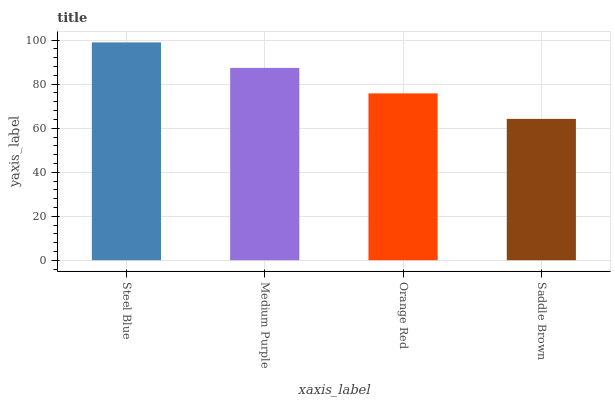Is Saddle Brown the minimum?
Answer yes or no. Yes. Is Steel Blue the maximum?
Answer yes or no. Yes. Is Medium Purple the minimum?
Answer yes or no. No. Is Medium Purple the maximum?
Answer yes or no. No. Is Steel Blue greater than Medium Purple?
Answer yes or no. Yes. Is Medium Purple less than Steel Blue?
Answer yes or no. Yes. Is Medium Purple greater than Steel Blue?
Answer yes or no. No. Is Steel Blue less than Medium Purple?
Answer yes or no. No. Is Medium Purple the high median?
Answer yes or no. Yes. Is Orange Red the low median?
Answer yes or no. Yes. Is Orange Red the high median?
Answer yes or no. No. Is Medium Purple the low median?
Answer yes or no. No. 